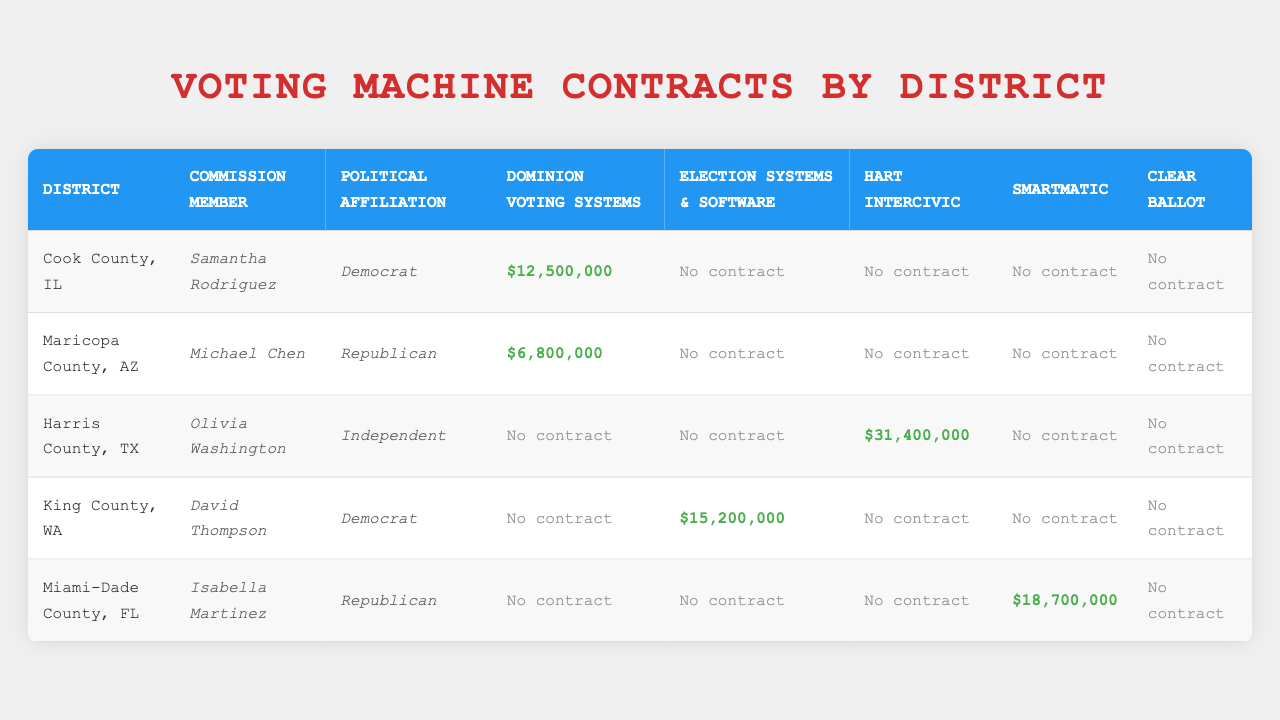What is the total contract value awarded to Dominion Voting Systems? The table shows that Dominion Voting Systems has contracts in Cook County for $12,500,000 and in Maricopa County for $6,800,000. Adding these values gives: 12,500,000 + 6,800,000 = 19,300,000.
Answer: $19,300,000 Which commission member is affiliated with the highest contract value? Looking at the contract values, Olivia Washington (Harris County) has a contract value of $31,400,000 for Hart InterCivic. This is higher than any values associated with other members.
Answer: Olivia Washington Are there any districts where no contracts were awarded? The table specifies contract values for each district. Both Cook County and Maricopa County awarded contracts, while Harris County, King County, and Miami-Dade County also designated specific amounts. Therefore, there are no districts with zero contractor values listed.
Answer: No What is the average contract value across all districts for Election Systems & Software? From the table, King County has a contract value of $15,200,000, while the other districts have $0. The average is calculated as (15,200,000) / (5 districts) = 3,040,000. Thus the average value is $3,040,000.
Answer: $3,040,000 Is there a correlation between political affiliation and the awarded contract values? By examining the table, we see that both Republican members (Michael Chen and Isabella Martinez) received zero contract money, while the Democrat members (Samantha Rodriguez and David Thompson) have significant contracts, indicating a potential correlation based on party affiliation to contract values.
Answer: Yes What is the difference in contract value between the highest and lowest awarded contracts? Harris County has the highest contract value of $31,400,000, while all contracts in Cook County, Maricopa County, King County, and Miami-Dade County with zero-awarded contracts are considered the lowest. Thus, the difference is calculated as: 31,400,000 - 0 = 31,400,000.
Answer: $31,400,000 Which district's commission member received the lowest contract value? Analyzing the table, both Cook County and Maricopa County award substantial amounts, while Miami-Dade County shows no contract value awarded via the commission member, Isabella Martinez. Therefore, she is considered as having the lowest value.
Answer: Isabella Martinez In which county did Smartmatic receive its highest contract value? From the table, Miami-Dade County has Smartmatic as its voting machine provider with a contract value of $18,700,000, which is the only Smartmatic contract reported.
Answer: Miami-Dade County How many total contracts were awarded across all districts? The total awarded contracts involve summing contract values from each district, which results in: 12,500,000 (Cook County) + 6,800,000 (Maricopa County) + 31,400,000 (Harris County) + 15,200,000 (King County) + 18,700,000 (Miami-Dade County) = 84,600,000.
Answer: $84,600,000 